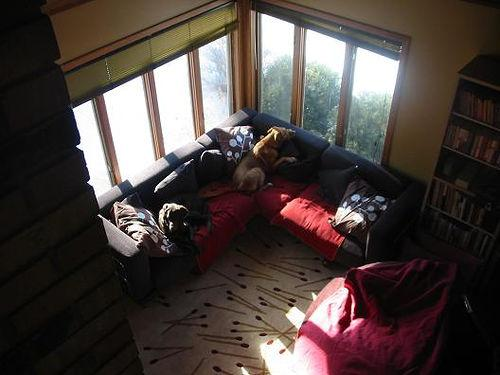What is on the couch? Please explain your reasoning. dog. He has four legs a long snout and drooping ears. 